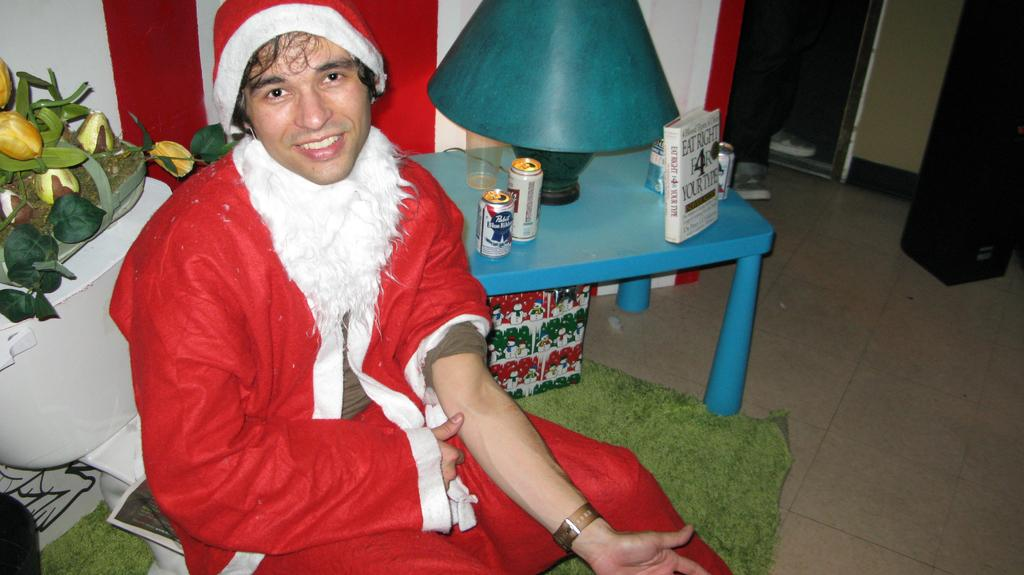What is the man wearing in the image? The man is wearing a Christmas dress. What is the man's position in the image? The man is sitting on a chair. What can be seen on the table in the image? There are tins, a lamp, and books on the table. What is the floor covering in the image? The floor has a carpet. What type of map is the man holding in the image? There is no map present in the image; the man is wearing a Christmas dress and sitting on a chair. 